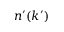<formula> <loc_0><loc_0><loc_500><loc_500>n ^ { \prime } ( k ^ { \prime } )</formula> 